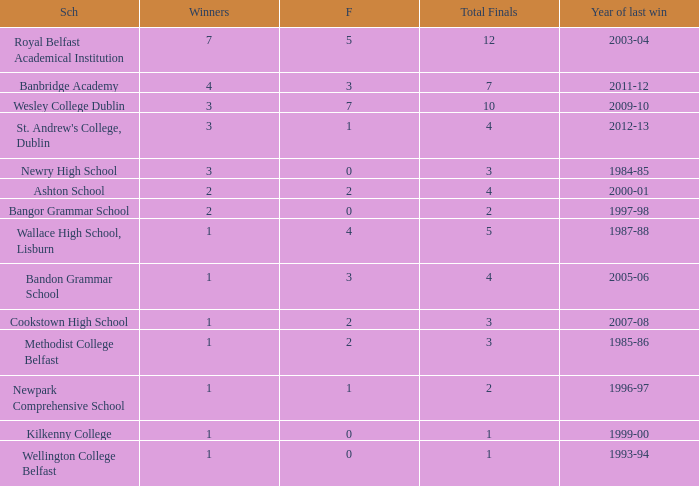What the name of  the school where the last win in 2007-08? Cookstown High School. 